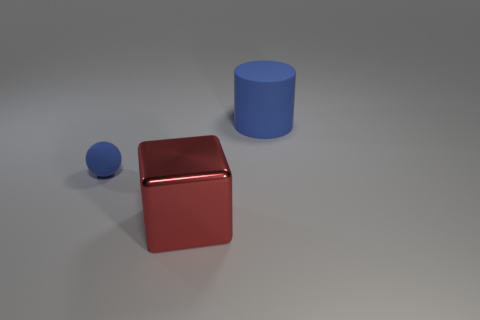What is the size of the blue thing that is left of the object that is behind the blue matte object to the left of the metal block?
Keep it short and to the point. Small. What color is the rubber thing in front of the rubber object right of the big block?
Make the answer very short. Blue. Is there anything else that has the same material as the cylinder?
Give a very brief answer. Yes. There is a big blue matte cylinder; are there any small spheres to the right of it?
Ensure brevity in your answer.  No. What number of big metal blocks are there?
Give a very brief answer. 1. How many big cubes are behind the matte thing that is on the right side of the small rubber thing?
Your response must be concise. 0. Does the large cube have the same color as the object that is behind the small rubber object?
Provide a succinct answer. No. There is a big object that is behind the red object; what material is it?
Keep it short and to the point. Rubber. Does the blue thing on the right side of the big metal object have the same shape as the small blue rubber object?
Your answer should be very brief. No. Is there a cyan matte block of the same size as the red metallic object?
Provide a short and direct response. No. 